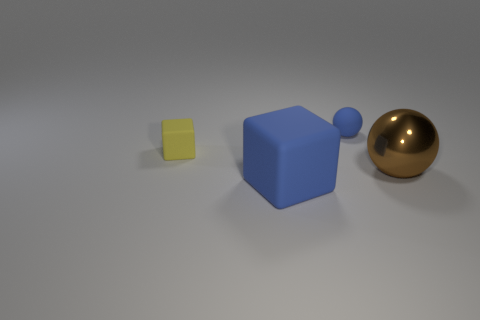Is there anything else that is the same shape as the large brown metallic object?
Keep it short and to the point. Yes. There is a big shiny object that is the same shape as the tiny blue thing; what is its color?
Offer a very short reply. Brown. What size is the blue sphere?
Make the answer very short. Small. Are there fewer tiny yellow matte blocks on the right side of the blue sphere than tiny rubber cylinders?
Offer a terse response. No. Is the material of the big cube the same as the blue thing behind the metal sphere?
Provide a short and direct response. Yes. Is there a small yellow matte block to the right of the object right of the small matte thing that is behind the tiny yellow block?
Your response must be concise. No. Is there anything else that is the same size as the blue block?
Offer a terse response. Yes. What color is the other block that is made of the same material as the yellow cube?
Make the answer very short. Blue. There is a object that is behind the big shiny object and to the left of the tiny blue ball; what size is it?
Offer a very short reply. Small. Is the number of small objects left of the tiny yellow cube less than the number of large brown metallic balls that are in front of the tiny blue ball?
Your answer should be very brief. Yes. 